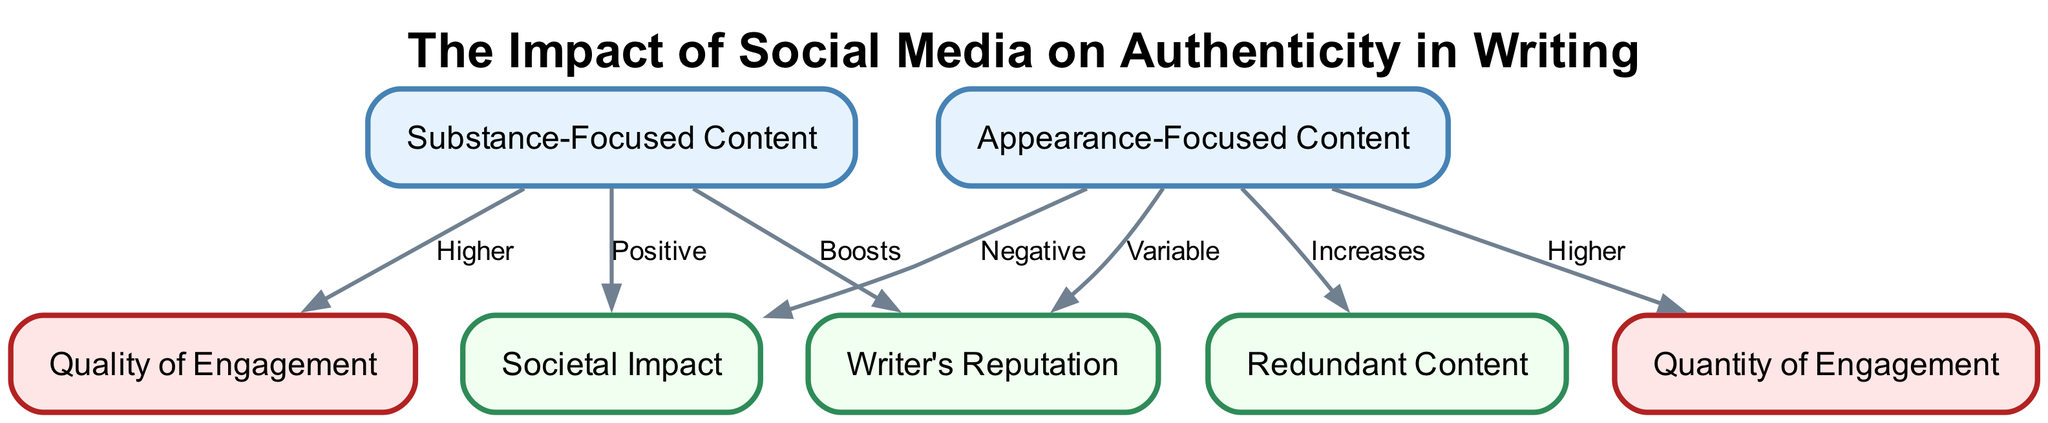What is the label of the node representing content that emphasizes depth and originality? This node is identified by the label "Substance-Focused Content," which explicitly states its focus on depth and originality in the description.
Answer: Substance-Focused Content How many nodes are present in the diagram? By counting all the unique entities listed in the nodes section of the data, we identify a total of seven distinct nodes.
Answer: 7 What is the relationship between Substance-Focused Content and Engagement Quality? The diagram shows an edge from Substance-Focused Content to Engagement Quality, labeled "Higher," indicating that substance-focused content typically results in greater engagement quality.
Answer: Higher Which type of content leads to more likes and shares? The edge from Appearance-Focused Content to Engagement Quantity is labeled "Higher," indicating that this type of content is more successful at garnering a larger number of likes and shares compared to substance-focused content.
Answer: Appearance-Focused Content What effect does Appearance-Focused Content have on Writer's Reputation? There is a connection indicating that the impact of Appearance-Focused Content on Writer's Reputation is "Variable," suggesting that it can differ based on other factors or perceptions of depth in the content.
Answer: Variable Which type of content fosters more thoughtful discussions? The connection from Substance-Focused Content to Societal Impact indicates a "Positive" effect, suggesting that it enriches cultural discourse and encourages deeper discussions.
Answer: Substance-Focused Content What does Redundant Content refer to in the diagram? Redundant Content is defined in the diagram as lacking originality and depth, often being repeated across platforms, which is linked to Appearance-Focused Content by an increase relationship.
Answer: Lacks originality and depth How does Substance-Focused Content impact Societal Impact? The diagram indicates a direct connection marked as "Positive" from Substance-Focused Content to Societal Impact, meaning it contributes positively to public discourse and cultural values.
Answer: Positive What type of content can contribute to superficial discourse? The edge from Appearance-Focused Content to Societal Impact is labeled "Negative," indicating that it can lead to shallow interactions and diminish the quality of cultural exchange.
Answer: Appearance-Focused Content 